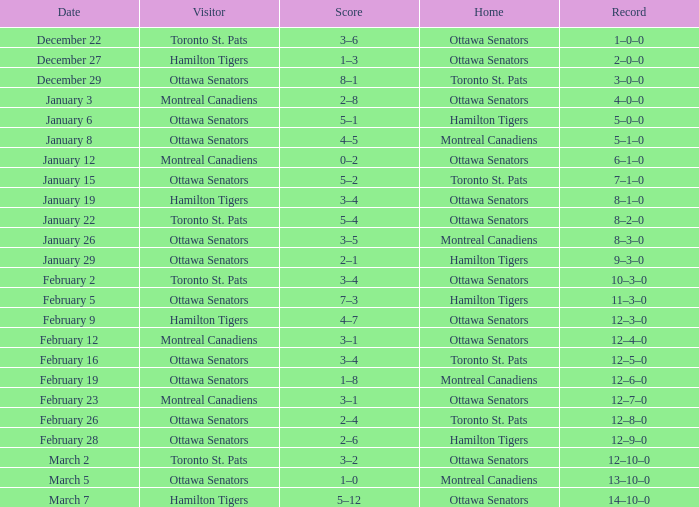What is the score of the game on January 12? 0–2. 